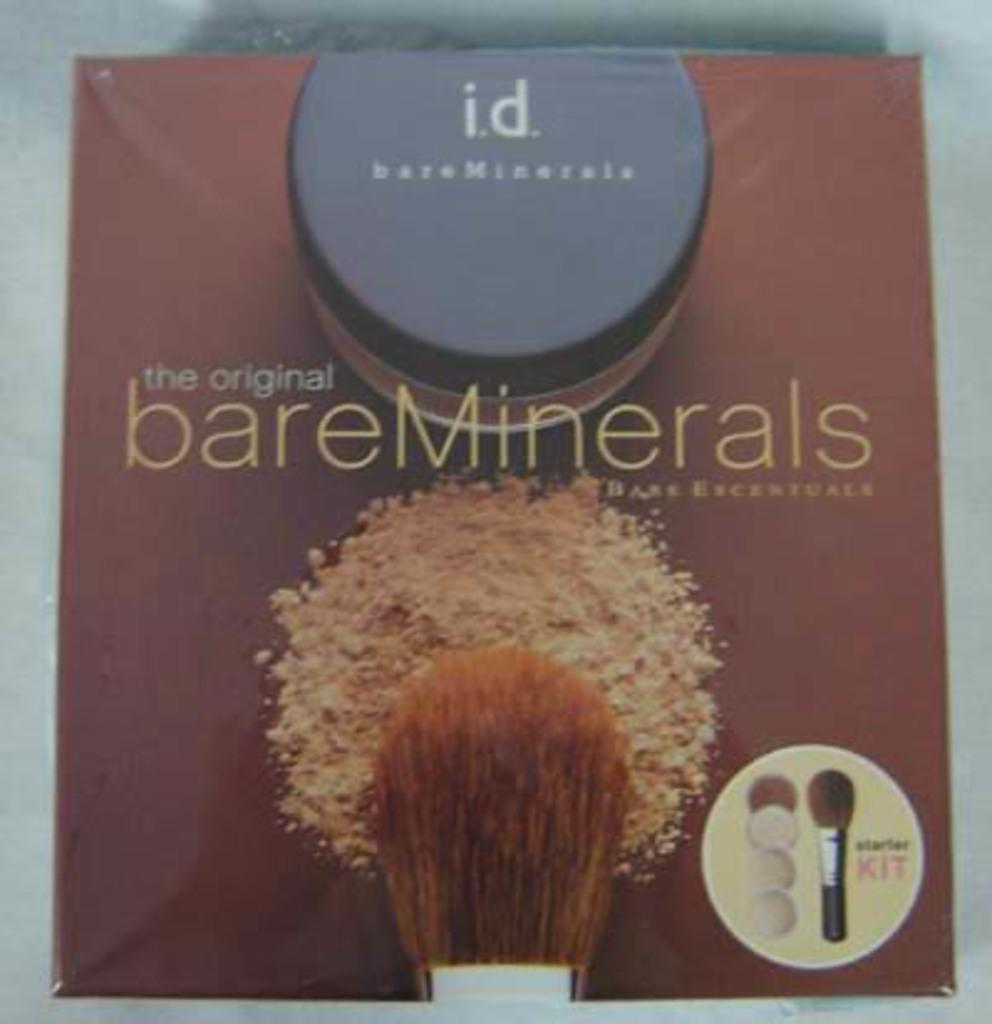<image>
Summarize the visual content of the image. Packaging for a bare minerals starter kit has a makeup brush on it. 